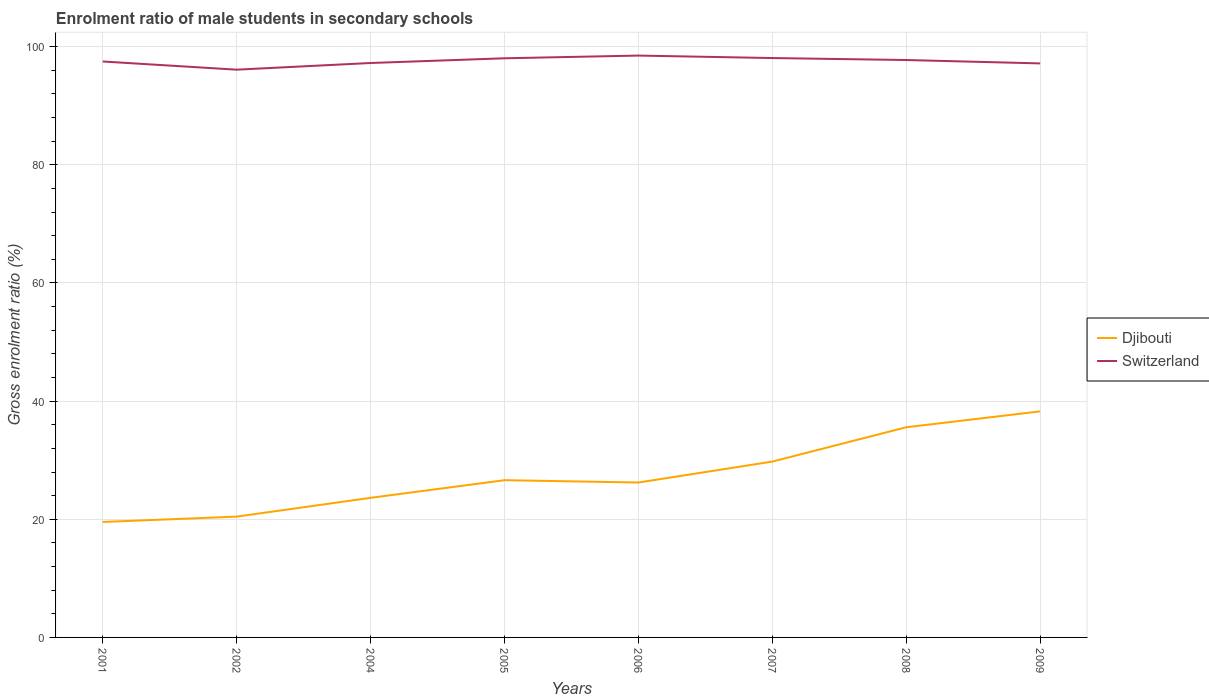How many different coloured lines are there?
Offer a very short reply. 2. Is the number of lines equal to the number of legend labels?
Offer a very short reply. Yes. Across all years, what is the maximum enrolment ratio of male students in secondary schools in Djibouti?
Keep it short and to the point. 19.54. What is the total enrolment ratio of male students in secondary schools in Switzerland in the graph?
Keep it short and to the point. -0.54. What is the difference between the highest and the second highest enrolment ratio of male students in secondary schools in Switzerland?
Ensure brevity in your answer.  2.39. What is the difference between the highest and the lowest enrolment ratio of male students in secondary schools in Djibouti?
Provide a succinct answer. 3. Where does the legend appear in the graph?
Your answer should be very brief. Center right. How are the legend labels stacked?
Provide a short and direct response. Vertical. What is the title of the graph?
Ensure brevity in your answer.  Enrolment ratio of male students in secondary schools. What is the label or title of the X-axis?
Provide a short and direct response. Years. What is the Gross enrolment ratio (%) of Djibouti in 2001?
Provide a succinct answer. 19.54. What is the Gross enrolment ratio (%) in Switzerland in 2001?
Offer a very short reply. 97.5. What is the Gross enrolment ratio (%) in Djibouti in 2002?
Ensure brevity in your answer.  20.45. What is the Gross enrolment ratio (%) in Switzerland in 2002?
Your response must be concise. 96.11. What is the Gross enrolment ratio (%) of Djibouti in 2004?
Give a very brief answer. 23.63. What is the Gross enrolment ratio (%) in Switzerland in 2004?
Your answer should be compact. 97.24. What is the Gross enrolment ratio (%) in Djibouti in 2005?
Your answer should be very brief. 26.62. What is the Gross enrolment ratio (%) of Switzerland in 2005?
Ensure brevity in your answer.  98.04. What is the Gross enrolment ratio (%) of Djibouti in 2006?
Offer a terse response. 26.22. What is the Gross enrolment ratio (%) of Switzerland in 2006?
Keep it short and to the point. 98.5. What is the Gross enrolment ratio (%) in Djibouti in 2007?
Provide a succinct answer. 29.77. What is the Gross enrolment ratio (%) of Switzerland in 2007?
Offer a terse response. 98.08. What is the Gross enrolment ratio (%) of Djibouti in 2008?
Offer a terse response. 35.58. What is the Gross enrolment ratio (%) of Switzerland in 2008?
Provide a succinct answer. 97.75. What is the Gross enrolment ratio (%) in Djibouti in 2009?
Offer a very short reply. 38.27. What is the Gross enrolment ratio (%) in Switzerland in 2009?
Offer a terse response. 97.17. Across all years, what is the maximum Gross enrolment ratio (%) of Djibouti?
Offer a very short reply. 38.27. Across all years, what is the maximum Gross enrolment ratio (%) of Switzerland?
Your answer should be very brief. 98.5. Across all years, what is the minimum Gross enrolment ratio (%) in Djibouti?
Provide a short and direct response. 19.54. Across all years, what is the minimum Gross enrolment ratio (%) in Switzerland?
Ensure brevity in your answer.  96.11. What is the total Gross enrolment ratio (%) in Djibouti in the graph?
Offer a very short reply. 220.08. What is the total Gross enrolment ratio (%) in Switzerland in the graph?
Ensure brevity in your answer.  780.38. What is the difference between the Gross enrolment ratio (%) of Djibouti in 2001 and that in 2002?
Keep it short and to the point. -0.9. What is the difference between the Gross enrolment ratio (%) in Switzerland in 2001 and that in 2002?
Your answer should be very brief. 1.39. What is the difference between the Gross enrolment ratio (%) of Djibouti in 2001 and that in 2004?
Give a very brief answer. -4.09. What is the difference between the Gross enrolment ratio (%) of Switzerland in 2001 and that in 2004?
Your answer should be very brief. 0.26. What is the difference between the Gross enrolment ratio (%) of Djibouti in 2001 and that in 2005?
Your answer should be very brief. -7.07. What is the difference between the Gross enrolment ratio (%) of Switzerland in 2001 and that in 2005?
Ensure brevity in your answer.  -0.54. What is the difference between the Gross enrolment ratio (%) in Djibouti in 2001 and that in 2006?
Offer a very short reply. -6.68. What is the difference between the Gross enrolment ratio (%) of Switzerland in 2001 and that in 2006?
Your response must be concise. -1. What is the difference between the Gross enrolment ratio (%) of Djibouti in 2001 and that in 2007?
Give a very brief answer. -10.22. What is the difference between the Gross enrolment ratio (%) of Switzerland in 2001 and that in 2007?
Ensure brevity in your answer.  -0.58. What is the difference between the Gross enrolment ratio (%) in Djibouti in 2001 and that in 2008?
Your answer should be very brief. -16.03. What is the difference between the Gross enrolment ratio (%) in Switzerland in 2001 and that in 2008?
Provide a succinct answer. -0.25. What is the difference between the Gross enrolment ratio (%) of Djibouti in 2001 and that in 2009?
Your answer should be very brief. -18.72. What is the difference between the Gross enrolment ratio (%) of Switzerland in 2001 and that in 2009?
Provide a short and direct response. 0.32. What is the difference between the Gross enrolment ratio (%) of Djibouti in 2002 and that in 2004?
Make the answer very short. -3.18. What is the difference between the Gross enrolment ratio (%) of Switzerland in 2002 and that in 2004?
Ensure brevity in your answer.  -1.13. What is the difference between the Gross enrolment ratio (%) in Djibouti in 2002 and that in 2005?
Your response must be concise. -6.17. What is the difference between the Gross enrolment ratio (%) in Switzerland in 2002 and that in 2005?
Your answer should be very brief. -1.93. What is the difference between the Gross enrolment ratio (%) in Djibouti in 2002 and that in 2006?
Keep it short and to the point. -5.78. What is the difference between the Gross enrolment ratio (%) of Switzerland in 2002 and that in 2006?
Give a very brief answer. -2.39. What is the difference between the Gross enrolment ratio (%) in Djibouti in 2002 and that in 2007?
Your response must be concise. -9.32. What is the difference between the Gross enrolment ratio (%) of Switzerland in 2002 and that in 2007?
Ensure brevity in your answer.  -1.97. What is the difference between the Gross enrolment ratio (%) of Djibouti in 2002 and that in 2008?
Provide a short and direct response. -15.13. What is the difference between the Gross enrolment ratio (%) of Switzerland in 2002 and that in 2008?
Ensure brevity in your answer.  -1.64. What is the difference between the Gross enrolment ratio (%) in Djibouti in 2002 and that in 2009?
Offer a terse response. -17.82. What is the difference between the Gross enrolment ratio (%) of Switzerland in 2002 and that in 2009?
Provide a short and direct response. -1.06. What is the difference between the Gross enrolment ratio (%) in Djibouti in 2004 and that in 2005?
Offer a terse response. -2.99. What is the difference between the Gross enrolment ratio (%) in Switzerland in 2004 and that in 2005?
Offer a very short reply. -0.8. What is the difference between the Gross enrolment ratio (%) in Djibouti in 2004 and that in 2006?
Your answer should be very brief. -2.59. What is the difference between the Gross enrolment ratio (%) in Switzerland in 2004 and that in 2006?
Provide a succinct answer. -1.26. What is the difference between the Gross enrolment ratio (%) of Djibouti in 2004 and that in 2007?
Offer a terse response. -6.14. What is the difference between the Gross enrolment ratio (%) of Switzerland in 2004 and that in 2007?
Offer a terse response. -0.84. What is the difference between the Gross enrolment ratio (%) of Djibouti in 2004 and that in 2008?
Provide a succinct answer. -11.95. What is the difference between the Gross enrolment ratio (%) in Switzerland in 2004 and that in 2008?
Ensure brevity in your answer.  -0.51. What is the difference between the Gross enrolment ratio (%) in Djibouti in 2004 and that in 2009?
Offer a terse response. -14.64. What is the difference between the Gross enrolment ratio (%) in Switzerland in 2004 and that in 2009?
Your response must be concise. 0.07. What is the difference between the Gross enrolment ratio (%) of Djibouti in 2005 and that in 2006?
Offer a terse response. 0.39. What is the difference between the Gross enrolment ratio (%) of Switzerland in 2005 and that in 2006?
Make the answer very short. -0.46. What is the difference between the Gross enrolment ratio (%) of Djibouti in 2005 and that in 2007?
Make the answer very short. -3.15. What is the difference between the Gross enrolment ratio (%) in Switzerland in 2005 and that in 2007?
Offer a terse response. -0.04. What is the difference between the Gross enrolment ratio (%) of Djibouti in 2005 and that in 2008?
Make the answer very short. -8.96. What is the difference between the Gross enrolment ratio (%) of Switzerland in 2005 and that in 2008?
Keep it short and to the point. 0.29. What is the difference between the Gross enrolment ratio (%) in Djibouti in 2005 and that in 2009?
Make the answer very short. -11.65. What is the difference between the Gross enrolment ratio (%) of Switzerland in 2005 and that in 2009?
Your response must be concise. 0.87. What is the difference between the Gross enrolment ratio (%) of Djibouti in 2006 and that in 2007?
Offer a terse response. -3.55. What is the difference between the Gross enrolment ratio (%) of Switzerland in 2006 and that in 2007?
Provide a succinct answer. 0.42. What is the difference between the Gross enrolment ratio (%) in Djibouti in 2006 and that in 2008?
Offer a terse response. -9.36. What is the difference between the Gross enrolment ratio (%) in Switzerland in 2006 and that in 2008?
Provide a succinct answer. 0.75. What is the difference between the Gross enrolment ratio (%) of Djibouti in 2006 and that in 2009?
Your answer should be very brief. -12.05. What is the difference between the Gross enrolment ratio (%) of Switzerland in 2006 and that in 2009?
Make the answer very short. 1.33. What is the difference between the Gross enrolment ratio (%) in Djibouti in 2007 and that in 2008?
Provide a short and direct response. -5.81. What is the difference between the Gross enrolment ratio (%) in Switzerland in 2007 and that in 2008?
Keep it short and to the point. 0.33. What is the difference between the Gross enrolment ratio (%) of Djibouti in 2007 and that in 2009?
Provide a succinct answer. -8.5. What is the difference between the Gross enrolment ratio (%) in Switzerland in 2007 and that in 2009?
Your answer should be compact. 0.91. What is the difference between the Gross enrolment ratio (%) in Djibouti in 2008 and that in 2009?
Your answer should be compact. -2.69. What is the difference between the Gross enrolment ratio (%) of Switzerland in 2008 and that in 2009?
Keep it short and to the point. 0.57. What is the difference between the Gross enrolment ratio (%) in Djibouti in 2001 and the Gross enrolment ratio (%) in Switzerland in 2002?
Provide a short and direct response. -76.57. What is the difference between the Gross enrolment ratio (%) in Djibouti in 2001 and the Gross enrolment ratio (%) in Switzerland in 2004?
Offer a terse response. -77.7. What is the difference between the Gross enrolment ratio (%) of Djibouti in 2001 and the Gross enrolment ratio (%) of Switzerland in 2005?
Offer a very short reply. -78.5. What is the difference between the Gross enrolment ratio (%) in Djibouti in 2001 and the Gross enrolment ratio (%) in Switzerland in 2006?
Provide a short and direct response. -78.95. What is the difference between the Gross enrolment ratio (%) of Djibouti in 2001 and the Gross enrolment ratio (%) of Switzerland in 2007?
Make the answer very short. -78.53. What is the difference between the Gross enrolment ratio (%) of Djibouti in 2001 and the Gross enrolment ratio (%) of Switzerland in 2008?
Provide a short and direct response. -78.2. What is the difference between the Gross enrolment ratio (%) in Djibouti in 2001 and the Gross enrolment ratio (%) in Switzerland in 2009?
Give a very brief answer. -77.63. What is the difference between the Gross enrolment ratio (%) of Djibouti in 2002 and the Gross enrolment ratio (%) of Switzerland in 2004?
Your answer should be compact. -76.79. What is the difference between the Gross enrolment ratio (%) of Djibouti in 2002 and the Gross enrolment ratio (%) of Switzerland in 2005?
Make the answer very short. -77.59. What is the difference between the Gross enrolment ratio (%) of Djibouti in 2002 and the Gross enrolment ratio (%) of Switzerland in 2006?
Give a very brief answer. -78.05. What is the difference between the Gross enrolment ratio (%) in Djibouti in 2002 and the Gross enrolment ratio (%) in Switzerland in 2007?
Offer a terse response. -77.63. What is the difference between the Gross enrolment ratio (%) in Djibouti in 2002 and the Gross enrolment ratio (%) in Switzerland in 2008?
Your answer should be compact. -77.3. What is the difference between the Gross enrolment ratio (%) of Djibouti in 2002 and the Gross enrolment ratio (%) of Switzerland in 2009?
Give a very brief answer. -76.73. What is the difference between the Gross enrolment ratio (%) of Djibouti in 2004 and the Gross enrolment ratio (%) of Switzerland in 2005?
Your response must be concise. -74.41. What is the difference between the Gross enrolment ratio (%) of Djibouti in 2004 and the Gross enrolment ratio (%) of Switzerland in 2006?
Keep it short and to the point. -74.87. What is the difference between the Gross enrolment ratio (%) in Djibouti in 2004 and the Gross enrolment ratio (%) in Switzerland in 2007?
Offer a very short reply. -74.45. What is the difference between the Gross enrolment ratio (%) of Djibouti in 2004 and the Gross enrolment ratio (%) of Switzerland in 2008?
Your answer should be very brief. -74.11. What is the difference between the Gross enrolment ratio (%) of Djibouti in 2004 and the Gross enrolment ratio (%) of Switzerland in 2009?
Ensure brevity in your answer.  -73.54. What is the difference between the Gross enrolment ratio (%) in Djibouti in 2005 and the Gross enrolment ratio (%) in Switzerland in 2006?
Give a very brief answer. -71.88. What is the difference between the Gross enrolment ratio (%) in Djibouti in 2005 and the Gross enrolment ratio (%) in Switzerland in 2007?
Give a very brief answer. -71.46. What is the difference between the Gross enrolment ratio (%) in Djibouti in 2005 and the Gross enrolment ratio (%) in Switzerland in 2008?
Your answer should be compact. -71.13. What is the difference between the Gross enrolment ratio (%) in Djibouti in 2005 and the Gross enrolment ratio (%) in Switzerland in 2009?
Offer a very short reply. -70.56. What is the difference between the Gross enrolment ratio (%) in Djibouti in 2006 and the Gross enrolment ratio (%) in Switzerland in 2007?
Provide a succinct answer. -71.86. What is the difference between the Gross enrolment ratio (%) of Djibouti in 2006 and the Gross enrolment ratio (%) of Switzerland in 2008?
Offer a terse response. -71.52. What is the difference between the Gross enrolment ratio (%) in Djibouti in 2006 and the Gross enrolment ratio (%) in Switzerland in 2009?
Offer a terse response. -70.95. What is the difference between the Gross enrolment ratio (%) of Djibouti in 2007 and the Gross enrolment ratio (%) of Switzerland in 2008?
Your response must be concise. -67.98. What is the difference between the Gross enrolment ratio (%) of Djibouti in 2007 and the Gross enrolment ratio (%) of Switzerland in 2009?
Make the answer very short. -67.4. What is the difference between the Gross enrolment ratio (%) of Djibouti in 2008 and the Gross enrolment ratio (%) of Switzerland in 2009?
Keep it short and to the point. -61.59. What is the average Gross enrolment ratio (%) of Djibouti per year?
Provide a succinct answer. 27.51. What is the average Gross enrolment ratio (%) of Switzerland per year?
Your answer should be compact. 97.55. In the year 2001, what is the difference between the Gross enrolment ratio (%) in Djibouti and Gross enrolment ratio (%) in Switzerland?
Your response must be concise. -77.95. In the year 2002, what is the difference between the Gross enrolment ratio (%) of Djibouti and Gross enrolment ratio (%) of Switzerland?
Your answer should be compact. -75.66. In the year 2004, what is the difference between the Gross enrolment ratio (%) of Djibouti and Gross enrolment ratio (%) of Switzerland?
Your response must be concise. -73.61. In the year 2005, what is the difference between the Gross enrolment ratio (%) of Djibouti and Gross enrolment ratio (%) of Switzerland?
Your response must be concise. -71.42. In the year 2006, what is the difference between the Gross enrolment ratio (%) of Djibouti and Gross enrolment ratio (%) of Switzerland?
Keep it short and to the point. -72.28. In the year 2007, what is the difference between the Gross enrolment ratio (%) in Djibouti and Gross enrolment ratio (%) in Switzerland?
Keep it short and to the point. -68.31. In the year 2008, what is the difference between the Gross enrolment ratio (%) in Djibouti and Gross enrolment ratio (%) in Switzerland?
Give a very brief answer. -62.17. In the year 2009, what is the difference between the Gross enrolment ratio (%) in Djibouti and Gross enrolment ratio (%) in Switzerland?
Give a very brief answer. -58.9. What is the ratio of the Gross enrolment ratio (%) of Djibouti in 2001 to that in 2002?
Make the answer very short. 0.96. What is the ratio of the Gross enrolment ratio (%) in Switzerland in 2001 to that in 2002?
Provide a succinct answer. 1.01. What is the ratio of the Gross enrolment ratio (%) in Djibouti in 2001 to that in 2004?
Your answer should be compact. 0.83. What is the ratio of the Gross enrolment ratio (%) in Switzerland in 2001 to that in 2004?
Offer a terse response. 1. What is the ratio of the Gross enrolment ratio (%) in Djibouti in 2001 to that in 2005?
Your answer should be compact. 0.73. What is the ratio of the Gross enrolment ratio (%) of Djibouti in 2001 to that in 2006?
Your answer should be compact. 0.75. What is the ratio of the Gross enrolment ratio (%) of Djibouti in 2001 to that in 2007?
Your response must be concise. 0.66. What is the ratio of the Gross enrolment ratio (%) of Djibouti in 2001 to that in 2008?
Offer a very short reply. 0.55. What is the ratio of the Gross enrolment ratio (%) of Djibouti in 2001 to that in 2009?
Ensure brevity in your answer.  0.51. What is the ratio of the Gross enrolment ratio (%) of Djibouti in 2002 to that in 2004?
Your answer should be very brief. 0.87. What is the ratio of the Gross enrolment ratio (%) of Switzerland in 2002 to that in 2004?
Your response must be concise. 0.99. What is the ratio of the Gross enrolment ratio (%) of Djibouti in 2002 to that in 2005?
Your response must be concise. 0.77. What is the ratio of the Gross enrolment ratio (%) in Switzerland in 2002 to that in 2005?
Make the answer very short. 0.98. What is the ratio of the Gross enrolment ratio (%) of Djibouti in 2002 to that in 2006?
Keep it short and to the point. 0.78. What is the ratio of the Gross enrolment ratio (%) in Switzerland in 2002 to that in 2006?
Your answer should be compact. 0.98. What is the ratio of the Gross enrolment ratio (%) in Djibouti in 2002 to that in 2007?
Keep it short and to the point. 0.69. What is the ratio of the Gross enrolment ratio (%) in Switzerland in 2002 to that in 2007?
Your answer should be compact. 0.98. What is the ratio of the Gross enrolment ratio (%) of Djibouti in 2002 to that in 2008?
Your answer should be very brief. 0.57. What is the ratio of the Gross enrolment ratio (%) in Switzerland in 2002 to that in 2008?
Provide a short and direct response. 0.98. What is the ratio of the Gross enrolment ratio (%) of Djibouti in 2002 to that in 2009?
Provide a short and direct response. 0.53. What is the ratio of the Gross enrolment ratio (%) of Switzerland in 2002 to that in 2009?
Make the answer very short. 0.99. What is the ratio of the Gross enrolment ratio (%) of Djibouti in 2004 to that in 2005?
Make the answer very short. 0.89. What is the ratio of the Gross enrolment ratio (%) in Djibouti in 2004 to that in 2006?
Keep it short and to the point. 0.9. What is the ratio of the Gross enrolment ratio (%) of Switzerland in 2004 to that in 2006?
Your answer should be compact. 0.99. What is the ratio of the Gross enrolment ratio (%) of Djibouti in 2004 to that in 2007?
Ensure brevity in your answer.  0.79. What is the ratio of the Gross enrolment ratio (%) of Switzerland in 2004 to that in 2007?
Your answer should be very brief. 0.99. What is the ratio of the Gross enrolment ratio (%) in Djibouti in 2004 to that in 2008?
Your response must be concise. 0.66. What is the ratio of the Gross enrolment ratio (%) of Djibouti in 2004 to that in 2009?
Ensure brevity in your answer.  0.62. What is the ratio of the Gross enrolment ratio (%) in Switzerland in 2005 to that in 2006?
Your answer should be very brief. 1. What is the ratio of the Gross enrolment ratio (%) of Djibouti in 2005 to that in 2007?
Keep it short and to the point. 0.89. What is the ratio of the Gross enrolment ratio (%) in Djibouti in 2005 to that in 2008?
Provide a short and direct response. 0.75. What is the ratio of the Gross enrolment ratio (%) in Switzerland in 2005 to that in 2008?
Provide a short and direct response. 1. What is the ratio of the Gross enrolment ratio (%) in Djibouti in 2005 to that in 2009?
Offer a very short reply. 0.7. What is the ratio of the Gross enrolment ratio (%) in Switzerland in 2005 to that in 2009?
Offer a terse response. 1.01. What is the ratio of the Gross enrolment ratio (%) in Djibouti in 2006 to that in 2007?
Offer a terse response. 0.88. What is the ratio of the Gross enrolment ratio (%) in Switzerland in 2006 to that in 2007?
Provide a short and direct response. 1. What is the ratio of the Gross enrolment ratio (%) in Djibouti in 2006 to that in 2008?
Offer a terse response. 0.74. What is the ratio of the Gross enrolment ratio (%) in Switzerland in 2006 to that in 2008?
Offer a very short reply. 1.01. What is the ratio of the Gross enrolment ratio (%) in Djibouti in 2006 to that in 2009?
Keep it short and to the point. 0.69. What is the ratio of the Gross enrolment ratio (%) in Switzerland in 2006 to that in 2009?
Provide a succinct answer. 1.01. What is the ratio of the Gross enrolment ratio (%) in Djibouti in 2007 to that in 2008?
Your response must be concise. 0.84. What is the ratio of the Gross enrolment ratio (%) of Djibouti in 2007 to that in 2009?
Provide a short and direct response. 0.78. What is the ratio of the Gross enrolment ratio (%) in Switzerland in 2007 to that in 2009?
Make the answer very short. 1.01. What is the ratio of the Gross enrolment ratio (%) of Djibouti in 2008 to that in 2009?
Provide a short and direct response. 0.93. What is the ratio of the Gross enrolment ratio (%) of Switzerland in 2008 to that in 2009?
Your response must be concise. 1.01. What is the difference between the highest and the second highest Gross enrolment ratio (%) in Djibouti?
Provide a succinct answer. 2.69. What is the difference between the highest and the second highest Gross enrolment ratio (%) of Switzerland?
Your response must be concise. 0.42. What is the difference between the highest and the lowest Gross enrolment ratio (%) in Djibouti?
Offer a terse response. 18.72. What is the difference between the highest and the lowest Gross enrolment ratio (%) of Switzerland?
Your answer should be compact. 2.39. 